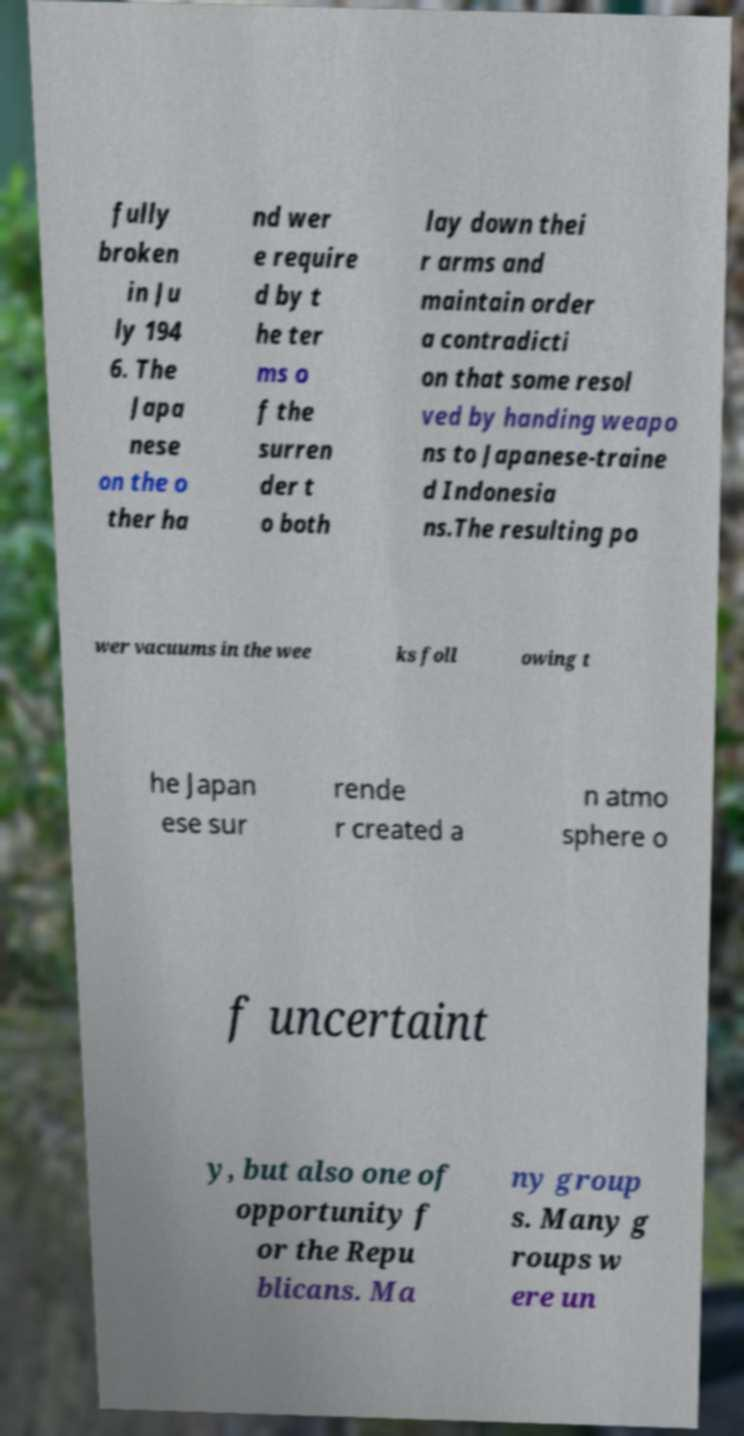Please identify and transcribe the text found in this image. fully broken in Ju ly 194 6. The Japa nese on the o ther ha nd wer e require d by t he ter ms o f the surren der t o both lay down thei r arms and maintain order a contradicti on that some resol ved by handing weapo ns to Japanese-traine d Indonesia ns.The resulting po wer vacuums in the wee ks foll owing t he Japan ese sur rende r created a n atmo sphere o f uncertaint y, but also one of opportunity f or the Repu blicans. Ma ny group s. Many g roups w ere un 